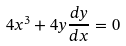Convert formula to latex. <formula><loc_0><loc_0><loc_500><loc_500>4 x ^ { 3 } + 4 y \frac { d y } { d x } = 0</formula> 